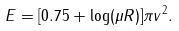<formula> <loc_0><loc_0><loc_500><loc_500>E = [ 0 . 7 5 + \log ( \mu R ) ] \pi v ^ { 2 } .</formula> 